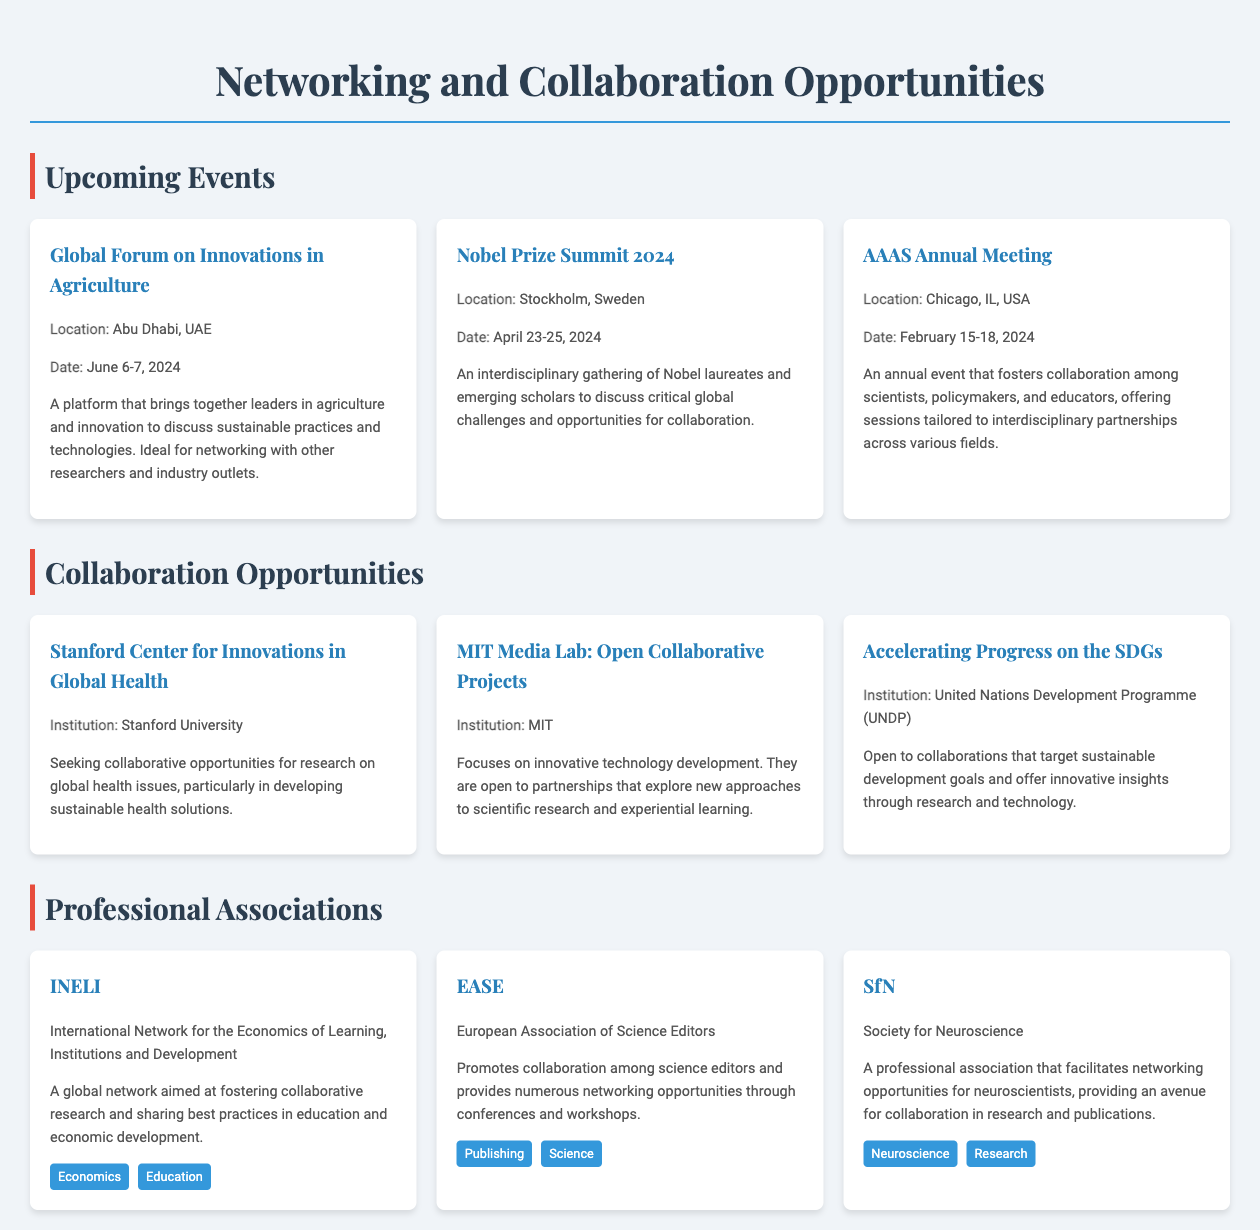What is the location of the Nobel Prize Summit 2024? The location of the Nobel Prize Summit 2024 is mentioned in the document as Stockholm, Sweden.
Answer: Stockholm, Sweden What are the dates for the AAAS Annual Meeting? The document specifies the AAAS Annual Meeting is scheduled for February 15-18, 2024.
Answer: February 15-18, 2024 Which institution is seeking research collaboration on global health issues? The document indicates that the Stanford Center for Innovations in Global Health is seeking such collaborations.
Answer: Stanford University What is a focus area of the MIT Media Lab's Open Collaborative Projects? The focus area for MIT Media Lab's Open Collaborative Projects is on innovative technology development.
Answer: Innovative technology development Which professional association promotes collaboration among science editors? The document states that EASE, the European Association of Science Editors, promotes collaboration among science editors.
Answer: EASE How many upcoming events are listed in the document? The document lists three upcoming events under the Upcoming Events section.
Answer: Three 